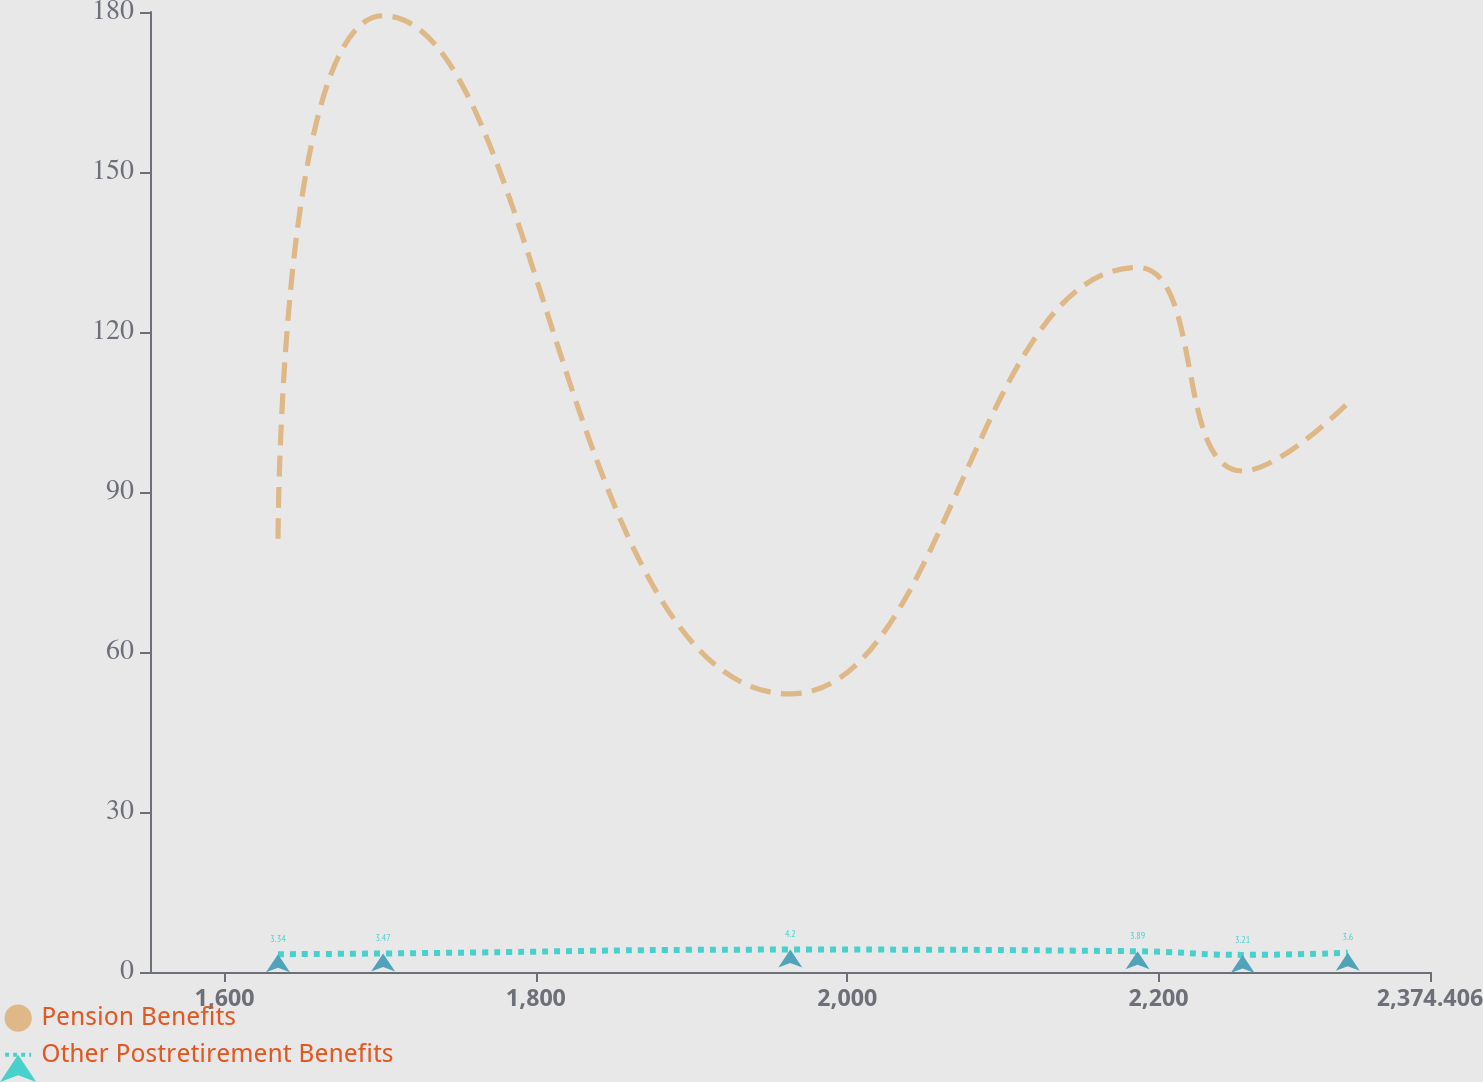Convert chart. <chart><loc_0><loc_0><loc_500><loc_500><line_chart><ecel><fcel>Pension Benefits<fcel>Other Postretirement Benefits<nl><fcel>1634.3<fcel>81.22<fcel>3.34<nl><fcel>1701.83<fcel>179.3<fcel>3.47<nl><fcel>1963.43<fcel>52.13<fcel>4.2<nl><fcel>2186.52<fcel>132.1<fcel>3.89<nl><fcel>2254.05<fcel>93.94<fcel>3.21<nl><fcel>2321.58<fcel>106.66<fcel>3.6<nl><fcel>2389.11<fcel>119.38<fcel>4.52<nl><fcel>2456.64<fcel>68.5<fcel>4.33<nl></chart> 